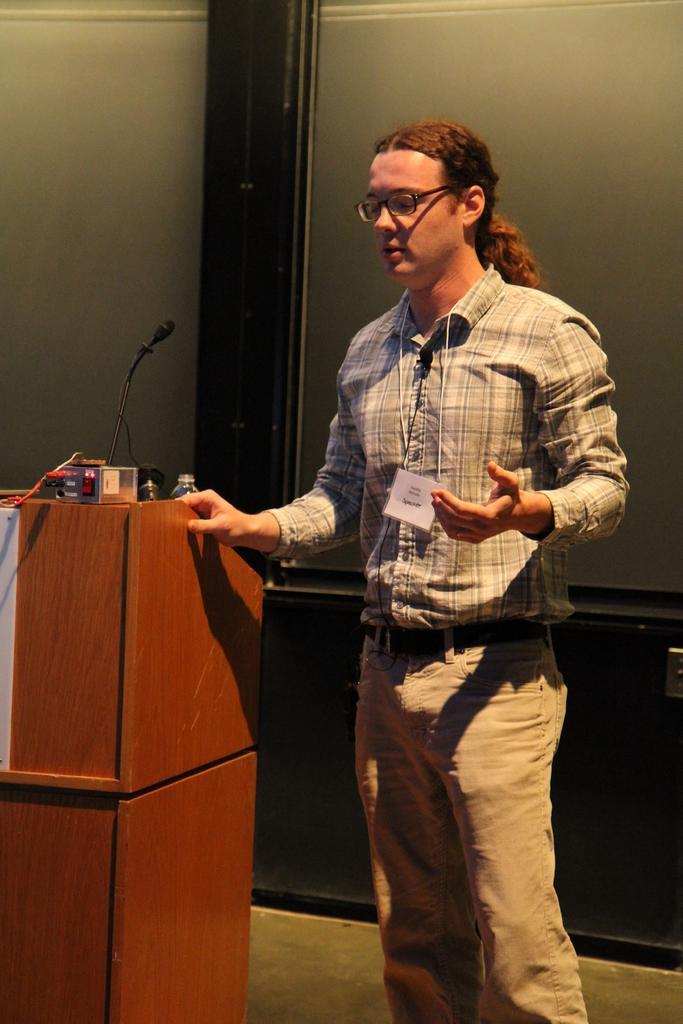Can you describe this image briefly? On the left side of the image there is a podium with mic, bottle and some other things. Beside the podium there is a man with spectacles and he is standing. Behind him there is a glass door. 